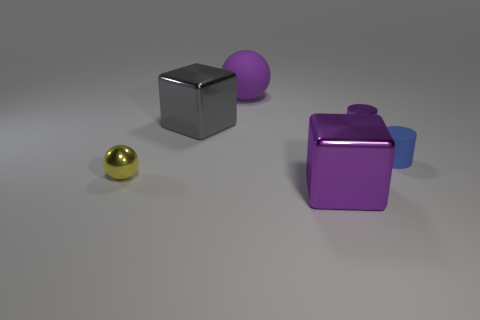Add 1 gray shiny things. How many objects exist? 7 Subtract all blocks. How many objects are left? 4 Add 3 small yellow shiny blocks. How many small yellow shiny blocks exist? 3 Subtract 1 purple cylinders. How many objects are left? 5 Subtract all tiny blue objects. Subtract all tiny purple shiny things. How many objects are left? 4 Add 4 big spheres. How many big spheres are left? 5 